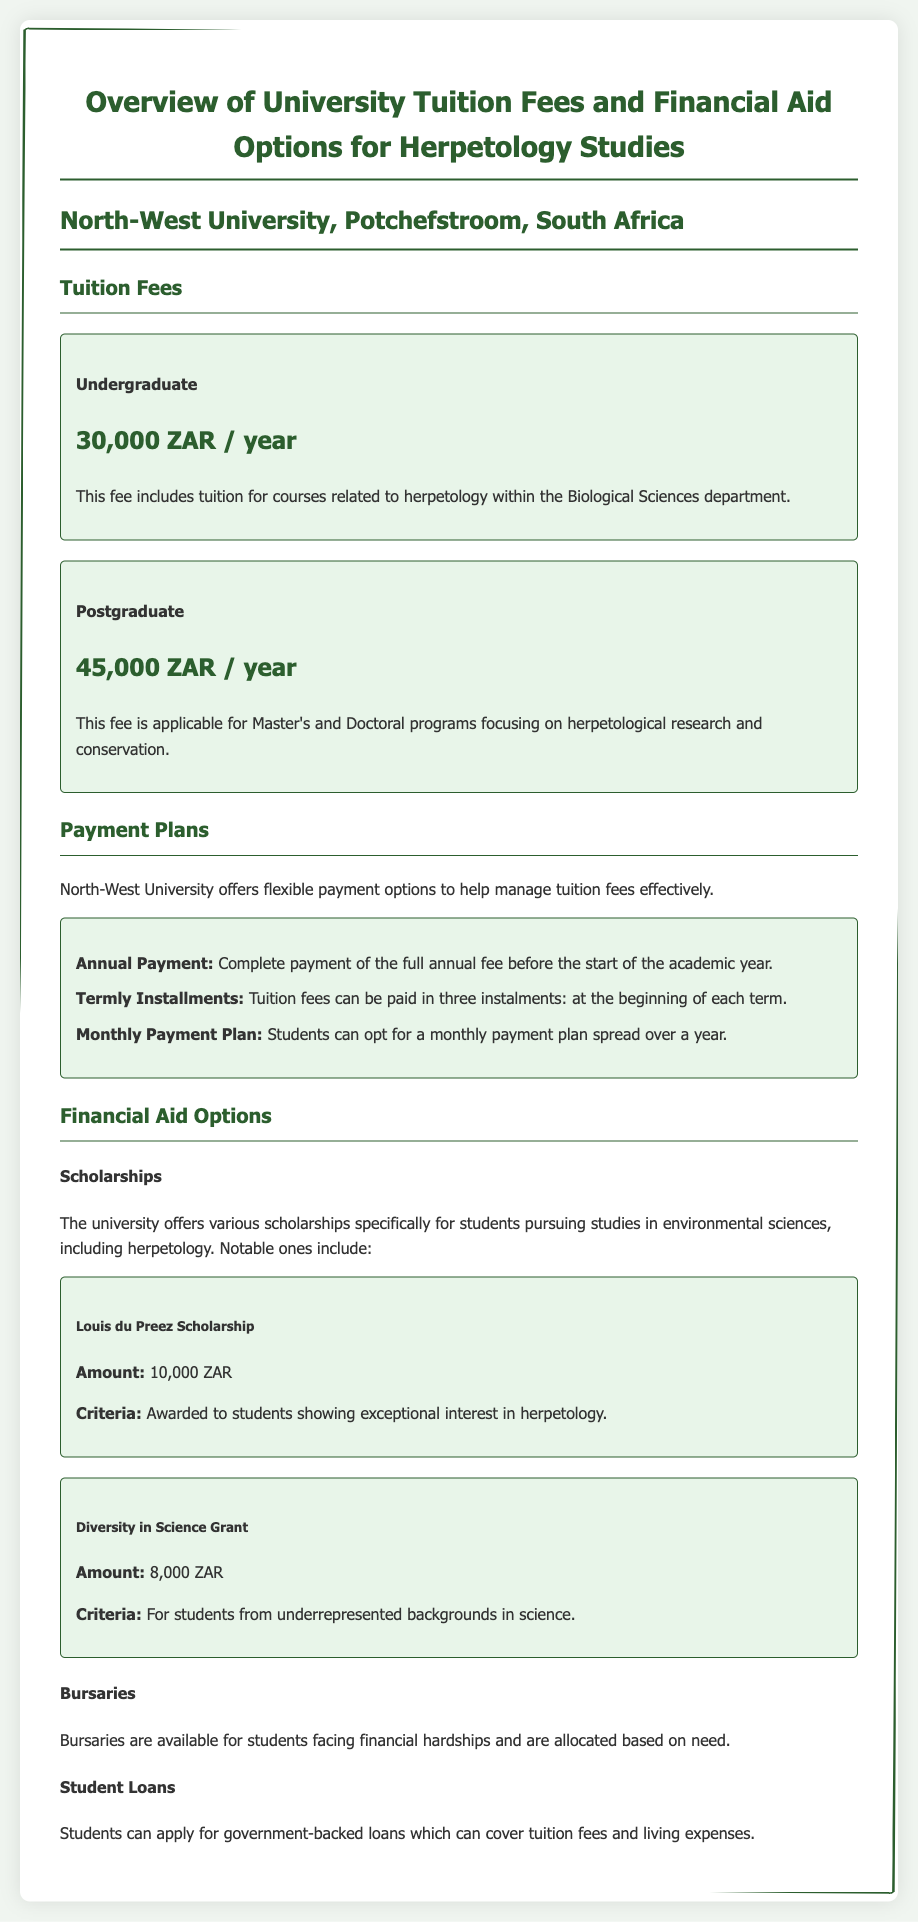What is the undergraduate tuition fee? The undergraduate tuition fee listed in the document is 30,000 ZAR / year.
Answer: 30,000 ZAR / year What is the postgraduate tuition fee? The postgraduate tuition fee detailed in the report is 45,000 ZAR / year.
Answer: 45,000 ZAR / year What payment option involves paying three times per year? The document mentions a termly installment option where fees are paid at the beginning of each term.
Answer: Termly Installments How much is the Louis du Preez Scholarship? The amount for the Louis du Preez Scholarship is explicitly stated in the document as 10,000 ZAR.
Answer: 10,000 ZAR What is the primary criteria for the Diversity in Science Grant? The document states that the criteria for the Diversity in Science Grant is for students from underrepresented backgrounds in science.
Answer: Underrepresented backgrounds in science What financial aid option is available for students facing hardships? The document refers to bursaries that are available for students facing financial hardships based on need.
Answer: Bursaries What payment plan allows students to spread payments over a year? The document specifies a monthly payment plan as a flexible option for tuition fee payments.
Answer: Monthly Payment Plan What is the purpose of the government-backed loans? The document indicates that government-backed loans cover tuition fees and living expenses.
Answer: Tuition fees and living expenses What department includes herpetology courses? The document states that herpetology courses are included in the Biological Sciences department.
Answer: Biological Sciences department 